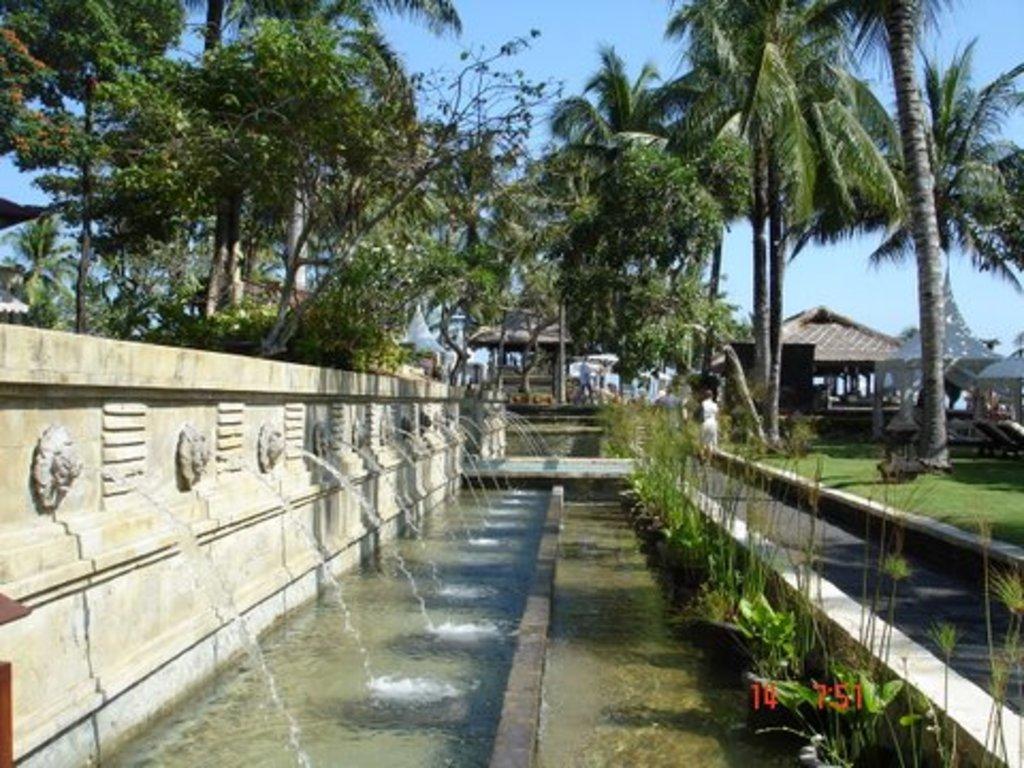Describe this image in one or two sentences. On the left side of the image we can see a fountain. At the bottom there is water and grass. In the background we can see people, trees, sheds and sky. 